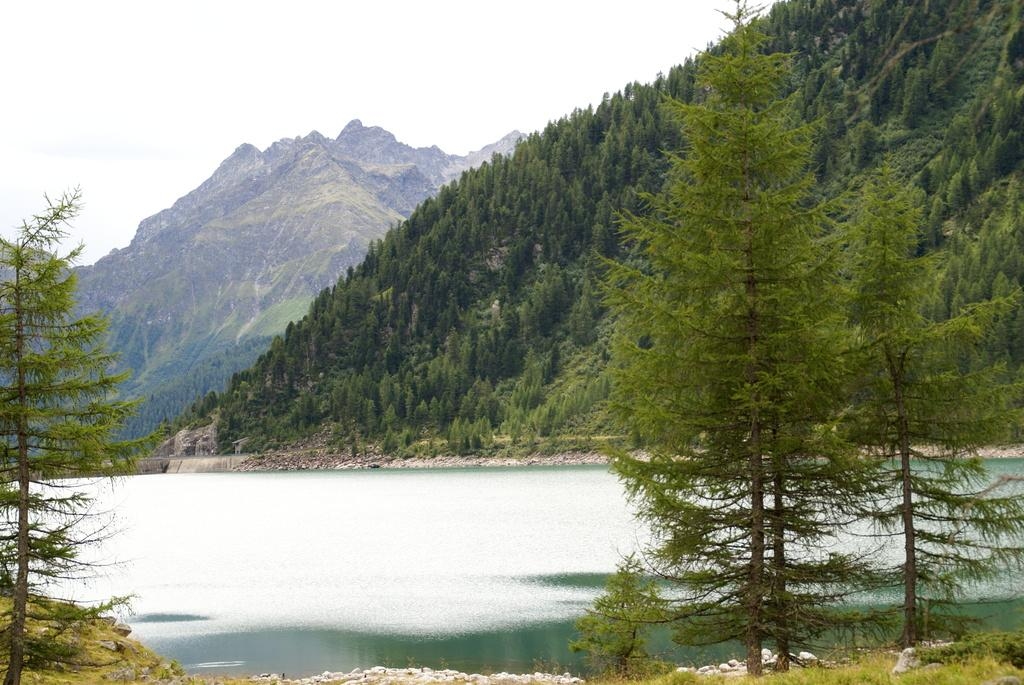What is the main feature in the middle of the image? There is a water body in the middle of the image. What can be seen in the foreground of the image? There are trees in the foreground of the image. What is visible in the background of the image? There are hills in the background of the image. Are there any trees on the hills? Yes, there are trees on the hills. What is the condition of the sky in the image? The sky is clear in the image. Can you tell me how many experts are standing in the garden in the image? There is no garden or experts present in the image. What type of push is being applied to the trees on the hills in the image? There is no push being applied to the trees on the hills in the image; they are simply standing on the hills. 